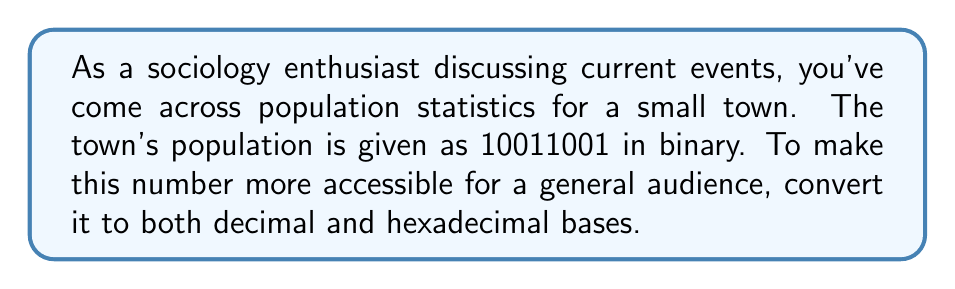Solve this math problem. Let's approach this step-by-step:

1) First, we'll convert the binary number to decimal:

   $10011001_2 = 1\cdot2^7 + 0\cdot2^6 + 0\cdot2^5 + 1\cdot2^4 + 1\cdot2^3 + 0\cdot2^2 + 0\cdot2^1 + 1\cdot2^0$

   $= 128 + 0 + 0 + 16 + 8 + 0 + 0 + 1$
   
   $= 153_{10}$

2) Now that we have the decimal number, we can convert it to hexadecimal:

   To convert to hexadecimal, we divide the decimal number by 16 repeatedly and keep track of the remainders:

   $153 \div 16 = 9$ remainder $9$
   $9 \div 16 = 0$ remainder $9$

   Reading the remainders from bottom to top gives us the hexadecimal digits.
   In hexadecimal, 9 remains 9, so our result is:

   $153_{10} = 99_{16}$

Therefore, the population of 10011001 in binary is equivalent to 153 in decimal and 99 in hexadecimal.
Answer: Decimal: $153_{10}$
Hexadecimal: $99_{16}$ 